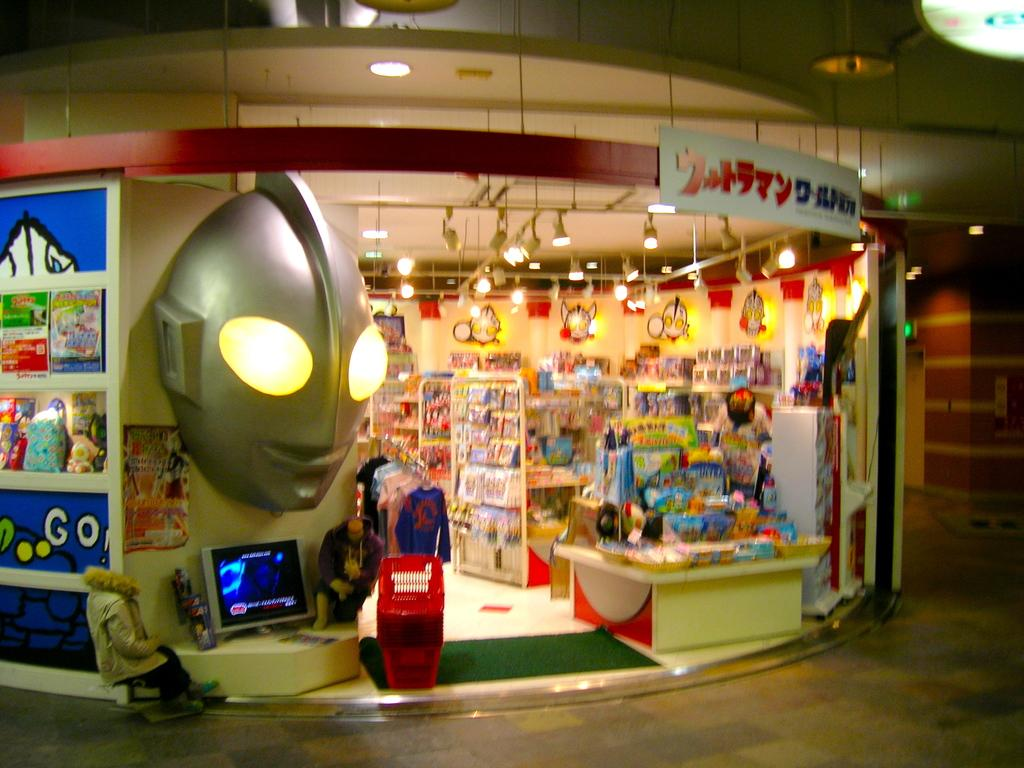<image>
Summarize the visual content of the image. A sign outside a games and toys store has the word GO on it. 